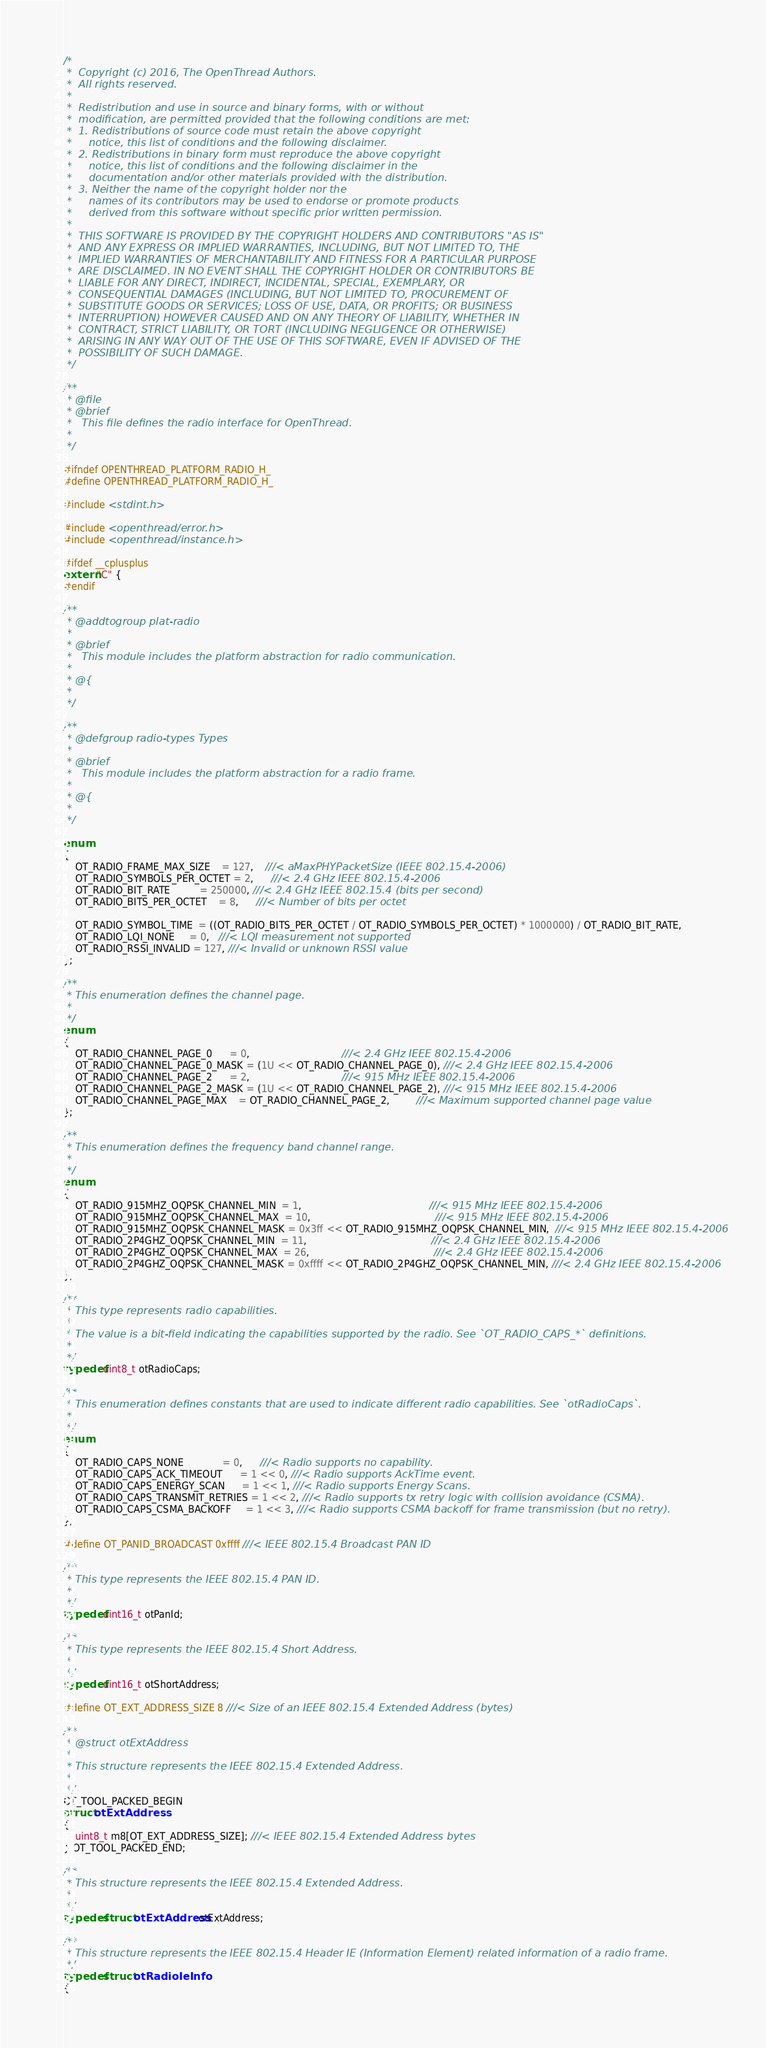<code> <loc_0><loc_0><loc_500><loc_500><_C_>/*
 *  Copyright (c) 2016, The OpenThread Authors.
 *  All rights reserved.
 *
 *  Redistribution and use in source and binary forms, with or without
 *  modification, are permitted provided that the following conditions are met:
 *  1. Redistributions of source code must retain the above copyright
 *     notice, this list of conditions and the following disclaimer.
 *  2. Redistributions in binary form must reproduce the above copyright
 *     notice, this list of conditions and the following disclaimer in the
 *     documentation and/or other materials provided with the distribution.
 *  3. Neither the name of the copyright holder nor the
 *     names of its contributors may be used to endorse or promote products
 *     derived from this software without specific prior written permission.
 *
 *  THIS SOFTWARE IS PROVIDED BY THE COPYRIGHT HOLDERS AND CONTRIBUTORS "AS IS"
 *  AND ANY EXPRESS OR IMPLIED WARRANTIES, INCLUDING, BUT NOT LIMITED TO, THE
 *  IMPLIED WARRANTIES OF MERCHANTABILITY AND FITNESS FOR A PARTICULAR PURPOSE
 *  ARE DISCLAIMED. IN NO EVENT SHALL THE COPYRIGHT HOLDER OR CONTRIBUTORS BE
 *  LIABLE FOR ANY DIRECT, INDIRECT, INCIDENTAL, SPECIAL, EXEMPLARY, OR
 *  CONSEQUENTIAL DAMAGES (INCLUDING, BUT NOT LIMITED TO, PROCUREMENT OF
 *  SUBSTITUTE GOODS OR SERVICES; LOSS OF USE, DATA, OR PROFITS; OR BUSINESS
 *  INTERRUPTION) HOWEVER CAUSED AND ON ANY THEORY OF LIABILITY, WHETHER IN
 *  CONTRACT, STRICT LIABILITY, OR TORT (INCLUDING NEGLIGENCE OR OTHERWISE)
 *  ARISING IN ANY WAY OUT OF THE USE OF THIS SOFTWARE, EVEN IF ADVISED OF THE
 *  POSSIBILITY OF SUCH DAMAGE.
 */

/**
 * @file
 * @brief
 *   This file defines the radio interface for OpenThread.
 *
 */

#ifndef OPENTHREAD_PLATFORM_RADIO_H_
#define OPENTHREAD_PLATFORM_RADIO_H_

#include <stdint.h>

#include <openthread/error.h>
#include <openthread/instance.h>

#ifdef __cplusplus
extern "C" {
#endif

/**
 * @addtogroup plat-radio
 *
 * @brief
 *   This module includes the platform abstraction for radio communication.
 *
 * @{
 *
 */

/**
 * @defgroup radio-types Types
 *
 * @brief
 *   This module includes the platform abstraction for a radio frame.
 *
 * @{
 *
 */

enum
{
    OT_RADIO_FRAME_MAX_SIZE    = 127,    ///< aMaxPHYPacketSize (IEEE 802.15.4-2006)
    OT_RADIO_SYMBOLS_PER_OCTET = 2,      ///< 2.4 GHz IEEE 802.15.4-2006
    OT_RADIO_BIT_RATE          = 250000, ///< 2.4 GHz IEEE 802.15.4 (bits per second)
    OT_RADIO_BITS_PER_OCTET    = 8,      ///< Number of bits per octet

    OT_RADIO_SYMBOL_TIME  = ((OT_RADIO_BITS_PER_OCTET / OT_RADIO_SYMBOLS_PER_OCTET) * 1000000) / OT_RADIO_BIT_RATE,
    OT_RADIO_LQI_NONE     = 0,   ///< LQI measurement not supported
    OT_RADIO_RSSI_INVALID = 127, ///< Invalid or unknown RSSI value
};

/**
 * This enumeration defines the channel page.
 *
 */
enum
{
    OT_RADIO_CHANNEL_PAGE_0      = 0,                               ///< 2.4 GHz IEEE 802.15.4-2006
    OT_RADIO_CHANNEL_PAGE_0_MASK = (1U << OT_RADIO_CHANNEL_PAGE_0), ///< 2.4 GHz IEEE 802.15.4-2006
    OT_RADIO_CHANNEL_PAGE_2      = 2,                               ///< 915 MHz IEEE 802.15.4-2006
    OT_RADIO_CHANNEL_PAGE_2_MASK = (1U << OT_RADIO_CHANNEL_PAGE_2), ///< 915 MHz IEEE 802.15.4-2006
    OT_RADIO_CHANNEL_PAGE_MAX    = OT_RADIO_CHANNEL_PAGE_2,         ///< Maximum supported channel page value
};

/**
 * This enumeration defines the frequency band channel range.
 *
 */
enum
{
    OT_RADIO_915MHZ_OQPSK_CHANNEL_MIN  = 1,                                           ///< 915 MHz IEEE 802.15.4-2006
    OT_RADIO_915MHZ_OQPSK_CHANNEL_MAX  = 10,                                          ///< 915 MHz IEEE 802.15.4-2006
    OT_RADIO_915MHZ_OQPSK_CHANNEL_MASK = 0x3ff << OT_RADIO_915MHZ_OQPSK_CHANNEL_MIN,  ///< 915 MHz IEEE 802.15.4-2006
    OT_RADIO_2P4GHZ_OQPSK_CHANNEL_MIN  = 11,                                          ///< 2.4 GHz IEEE 802.15.4-2006
    OT_RADIO_2P4GHZ_OQPSK_CHANNEL_MAX  = 26,                                          ///< 2.4 GHz IEEE 802.15.4-2006
    OT_RADIO_2P4GHZ_OQPSK_CHANNEL_MASK = 0xffff << OT_RADIO_2P4GHZ_OQPSK_CHANNEL_MIN, ///< 2.4 GHz IEEE 802.15.4-2006
};

/**
 * This type represents radio capabilities.
 *
 * The value is a bit-field indicating the capabilities supported by the radio. See `OT_RADIO_CAPS_*` definitions.
 *
 */
typedef uint8_t otRadioCaps;

/**
 * This enumeration defines constants that are used to indicate different radio capabilities. See `otRadioCaps`.
 *
 */
enum
{
    OT_RADIO_CAPS_NONE             = 0,      ///< Radio supports no capability.
    OT_RADIO_CAPS_ACK_TIMEOUT      = 1 << 0, ///< Radio supports AckTime event.
    OT_RADIO_CAPS_ENERGY_SCAN      = 1 << 1, ///< Radio supports Energy Scans.
    OT_RADIO_CAPS_TRANSMIT_RETRIES = 1 << 2, ///< Radio supports tx retry logic with collision avoidance (CSMA).
    OT_RADIO_CAPS_CSMA_BACKOFF     = 1 << 3, ///< Radio supports CSMA backoff for frame transmission (but no retry).
};

#define OT_PANID_BROADCAST 0xffff ///< IEEE 802.15.4 Broadcast PAN ID

/**
 * This type represents the IEEE 802.15.4 PAN ID.
 *
 */
typedef uint16_t otPanId;

/**
 * This type represents the IEEE 802.15.4 Short Address.
 *
 */
typedef uint16_t otShortAddress;

#define OT_EXT_ADDRESS_SIZE 8 ///< Size of an IEEE 802.15.4 Extended Address (bytes)

/**
 * @struct otExtAddress
 *
 * This structure represents the IEEE 802.15.4 Extended Address.
 *
 */
OT_TOOL_PACKED_BEGIN
struct otExtAddress
{
    uint8_t m8[OT_EXT_ADDRESS_SIZE]; ///< IEEE 802.15.4 Extended Address bytes
} OT_TOOL_PACKED_END;

/**
 * This structure represents the IEEE 802.15.4 Extended Address.
 *
 */
typedef struct otExtAddress otExtAddress;

/**
 * This structure represents the IEEE 802.15.4 Header IE (Information Element) related information of a radio frame.
 */
typedef struct otRadioIeInfo
{</code> 